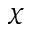Convert formula to latex. <formula><loc_0><loc_0><loc_500><loc_500>\chi</formula> 